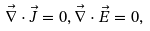Convert formula to latex. <formula><loc_0><loc_0><loc_500><loc_500>\vec { \nabla } \cdot \vec { J } = 0 , \vec { \nabla } \cdot \vec { E } = 0 ,</formula> 